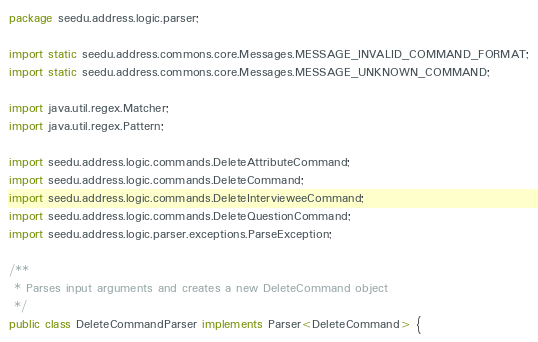<code> <loc_0><loc_0><loc_500><loc_500><_Java_>package seedu.address.logic.parser;

import static seedu.address.commons.core.Messages.MESSAGE_INVALID_COMMAND_FORMAT;
import static seedu.address.commons.core.Messages.MESSAGE_UNKNOWN_COMMAND;

import java.util.regex.Matcher;
import java.util.regex.Pattern;

import seedu.address.logic.commands.DeleteAttributeCommand;
import seedu.address.logic.commands.DeleteCommand;
import seedu.address.logic.commands.DeleteIntervieweeCommand;
import seedu.address.logic.commands.DeleteQuestionCommand;
import seedu.address.logic.parser.exceptions.ParseException;

/**
 * Parses input arguments and creates a new DeleteCommand object
 */
public class DeleteCommandParser implements Parser<DeleteCommand> {
</code> 